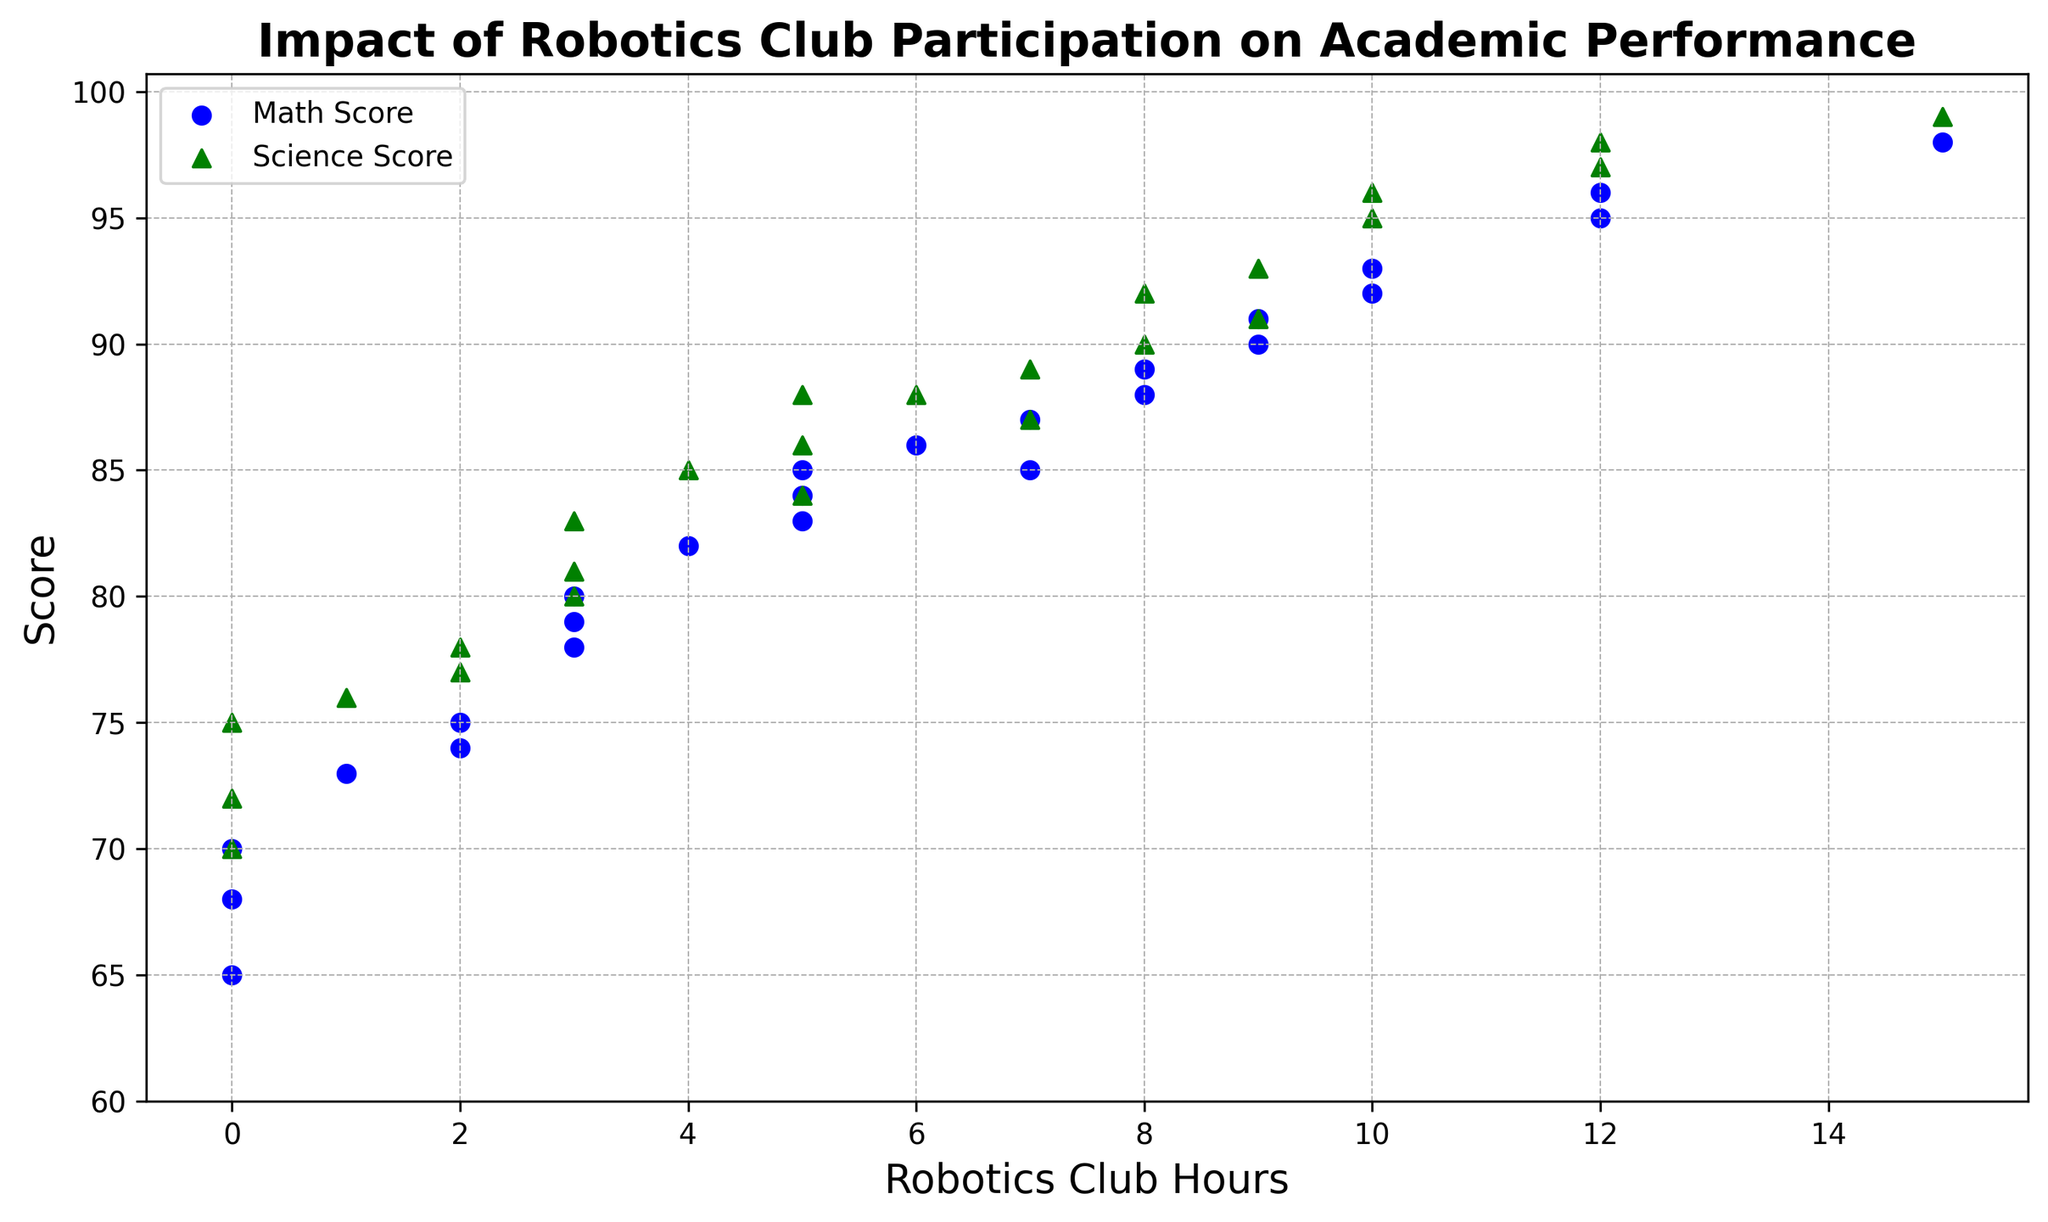What is the range of math scores represented in the figure? To find the range, identify the minimum and maximum values on the math score axis. According to the figure, the minimum math score is 65, and the maximum is 98. The range is the difference between these values: 98 - 65 = 33.
Answer: 33 Which science score corresponds to 10 hours of robotics club participation? Locate the point where robotics club hours are 10 on the horizontal axis, then find the corresponding science score by looking at the green marker at this point. The green marker for 10 hours of participation is at a science score of 96.
Answer: 96 Do students who spend 0 hours in the robotics club score higher in math or science on average? Observe the data points where robotics club hours are 0. Identify the math and science scores for these points: math scores are 70, 65, and 68 and science scores are 75, 70, and 72. Calculate the averages for both: Math: (70 + 65 + 68) / 3 = 67.67; Science: (75 + 70 + 72) / 3 = 72.33. Hence, these students score higher in science on average.
Answer: Science What is the general trend between robotics club hours and academic performance? To determine the trend, observe the distribution of points. Both blue and green markers (representing math and science scores respectively) generally increase as robotics club hours increase, indicating a positive correlation between robotics club hours and academic performance in both subjects.
Answer: Positive correlation For 7 hours of robotics club participation, did any student score the same in math and science? Locate the points where robotics club hours are 7. Identify the math and science scores for these points: math score of 87 and science score of 89; no student scored the same in both subjects.
Answer: No How many students spent more than 5 hours in the robotics club and scored above 90 in science? Identify data points where robotics club hours are greater than 5 and the green markers (science scores) are above 90. The students meeting both criteria are those with 9, 10, 12, and 15 hours of participation, having science scores of 93, 96, 97, and 99 respectively. Count these data points, totaling 4 students.
Answer: 4 Is there any student who participated in the robotics club for 8 hours and had the same math score as science score? Locate the points where robotics club hours are 8. Identify the math and science scores for these points: math score of 88 and science score of 90; no student had the same score in both subjects.
Answer: No What is the math score for the student who has the highest science score? Find the highest point among the green markers (science scores). The highest science score is 99, corresponding to 15 hours of robotics club participation. Check the blue marker (math score) at this same point, which is 98.
Answer: 98 What is the average increase in math scores from 0 to 12 hours of robotics club participation? Identify the math scores for 0 hours (70, 65, 68) and for 12 hours (95, 96). Calculate their respective averages: (70 + 65 + 68) / 3 = 67.67 for 0 hours, and (95 + 96) / 2 = 95.5 for 12 hours. The increase is 95.5 - 67.67 = 27.83 on average.
Answer: 27.83 